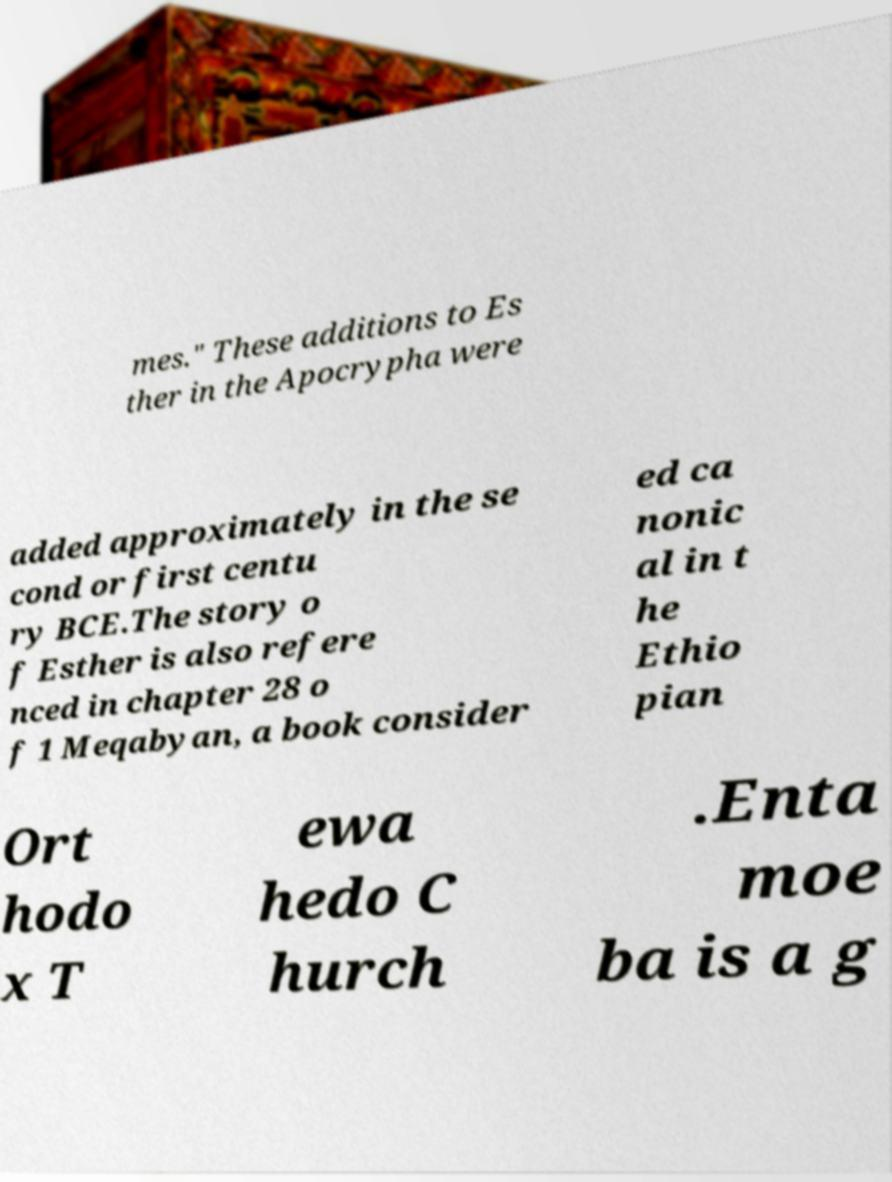Can you read and provide the text displayed in the image?This photo seems to have some interesting text. Can you extract and type it out for me? mes." These additions to Es ther in the Apocrypha were added approximately in the se cond or first centu ry BCE.The story o f Esther is also refere nced in chapter 28 o f 1 Meqabyan, a book consider ed ca nonic al in t he Ethio pian Ort hodo x T ewa hedo C hurch .Enta moe ba is a g 